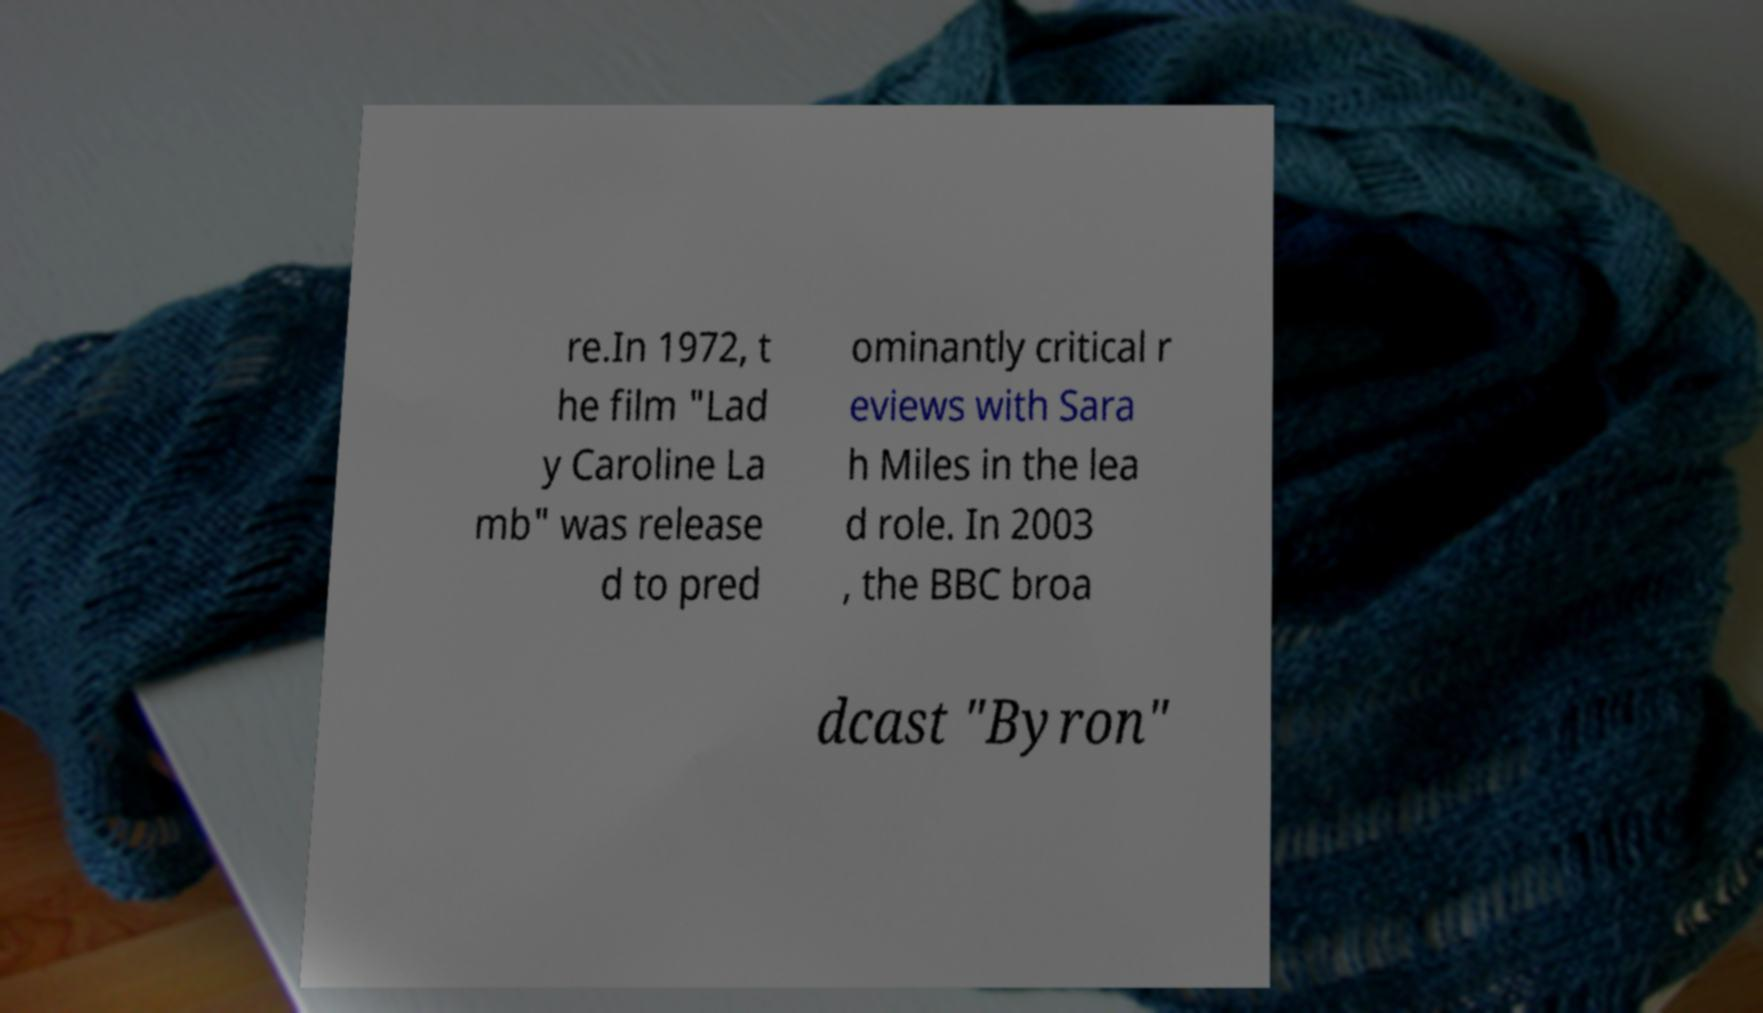Could you assist in decoding the text presented in this image and type it out clearly? re.In 1972, t he film "Lad y Caroline La mb" was release d to pred ominantly critical r eviews with Sara h Miles in the lea d role. In 2003 , the BBC broa dcast "Byron" 